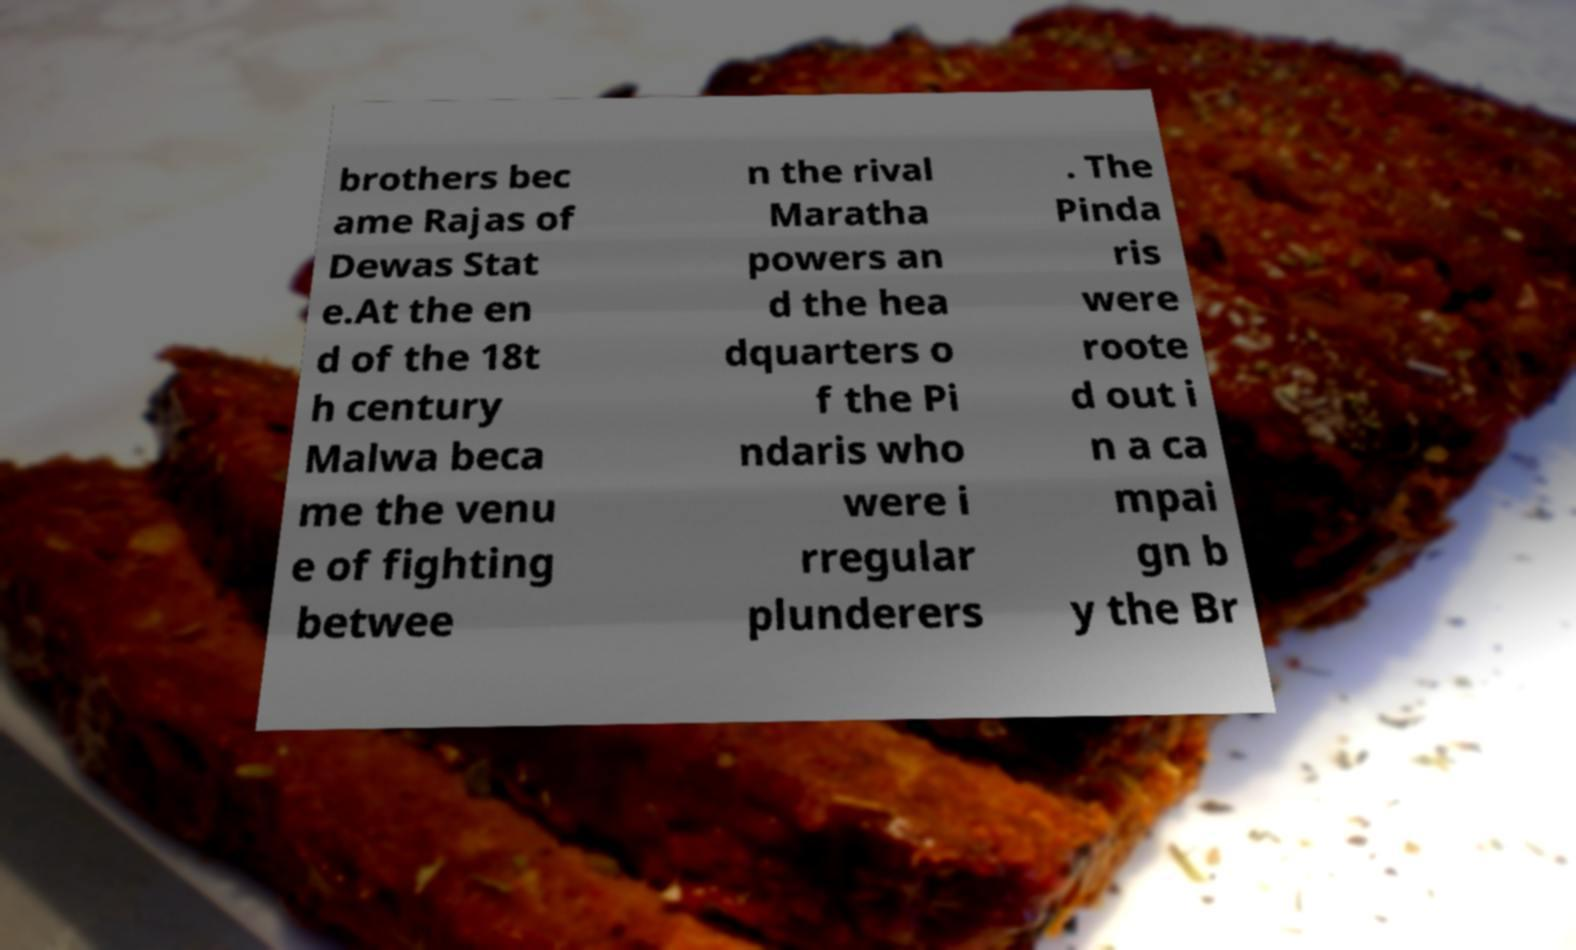Please read and relay the text visible in this image. What does it say? brothers bec ame Rajas of Dewas Stat e.At the en d of the 18t h century Malwa beca me the venu e of fighting betwee n the rival Maratha powers an d the hea dquarters o f the Pi ndaris who were i rregular plunderers . The Pinda ris were roote d out i n a ca mpai gn b y the Br 